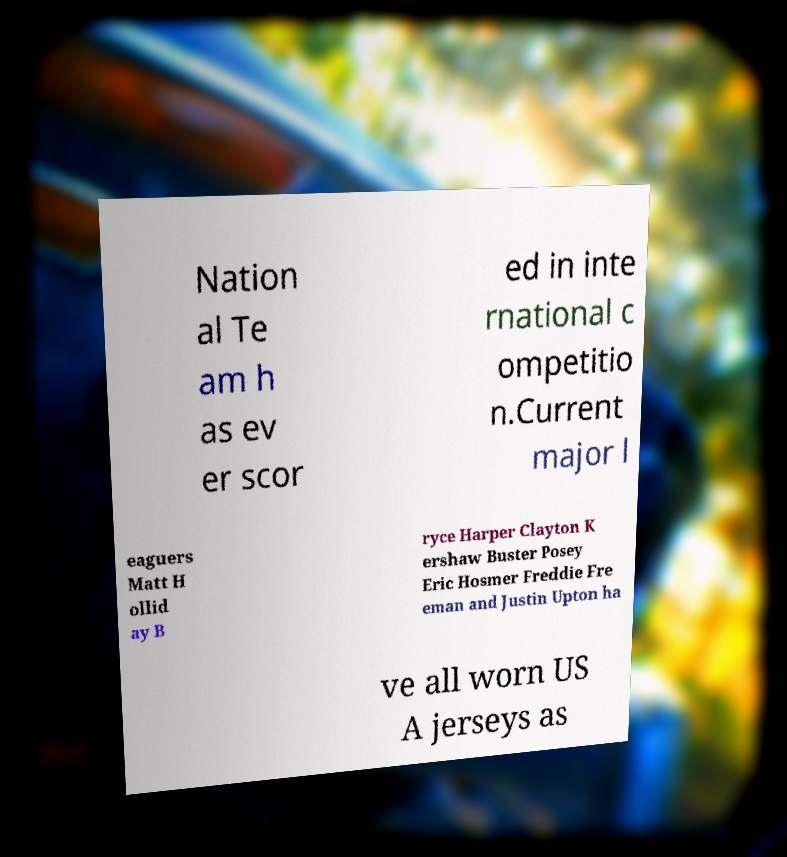Please read and relay the text visible in this image. What does it say? Nation al Te am h as ev er scor ed in inte rnational c ompetitio n.Current major l eaguers Matt H ollid ay B ryce Harper Clayton K ershaw Buster Posey Eric Hosmer Freddie Fre eman and Justin Upton ha ve all worn US A jerseys as 